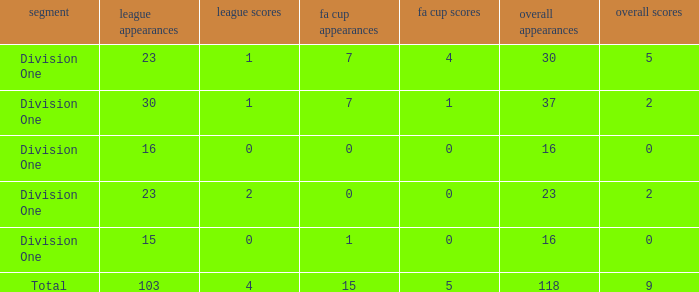The total goals have a FA Cup Apps larger than 1, and a Total Apps of 37, and a League Apps smaller than 30?, what is the total number? 0.0. 